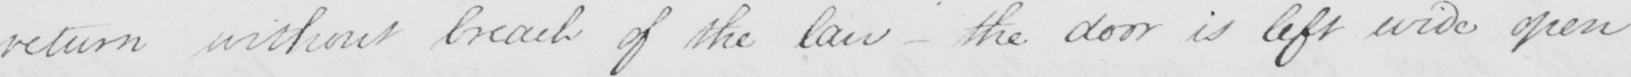Can you tell me what this handwritten text says? return without break of the law  _  the door is left wide open 